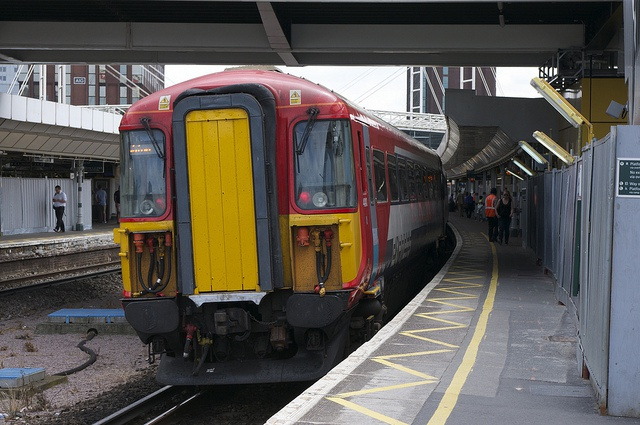Describe the objects in this image and their specific colors. I can see train in black, gray, olive, and maroon tones, people in black and gray tones, people in black and gray tones, people in black, maroon, gray, and brown tones, and people in black, gray, and darkblue tones in this image. 